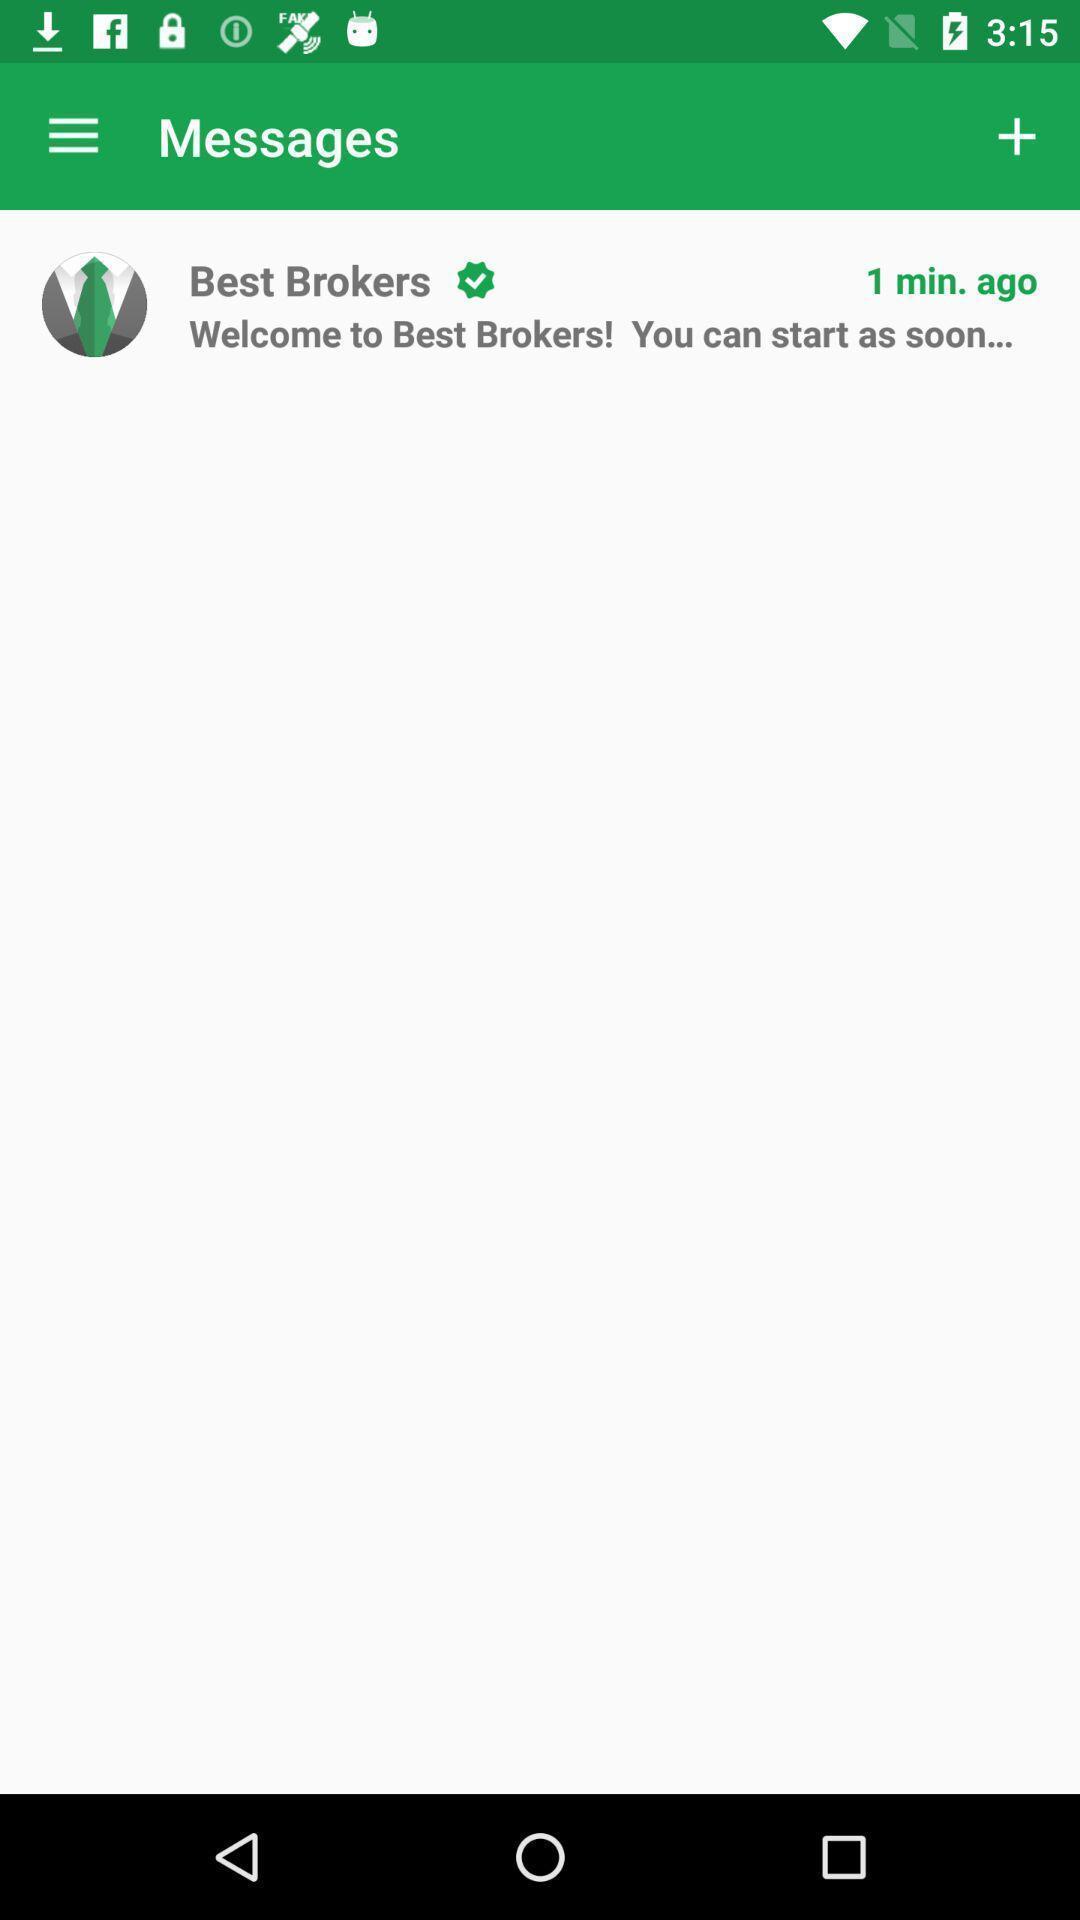Tell me what you see in this picture. Page showing the listing in messages tab. 